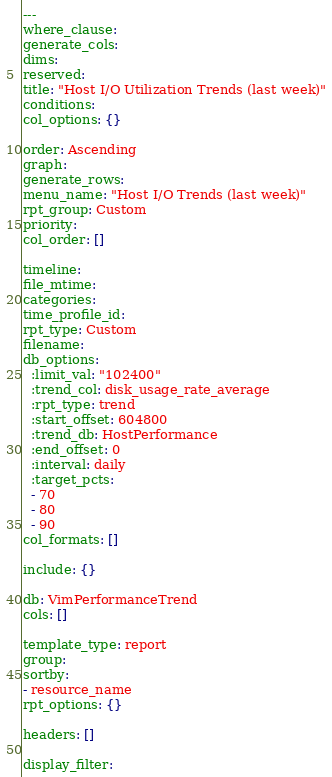Convert code to text. <code><loc_0><loc_0><loc_500><loc_500><_YAML_>---
where_clause:
generate_cols:
dims:
reserved:
title: "Host I/O Utilization Trends (last week)"
conditions:
col_options: {}

order: Ascending
graph:
generate_rows:
menu_name: "Host I/O Trends (last week)"
rpt_group: Custom
priority:
col_order: []

timeline:
file_mtime:
categories:
time_profile_id:
rpt_type: Custom
filename:
db_options:
  :limit_val: "102400"
  :trend_col: disk_usage_rate_average
  :rpt_type: trend
  :start_offset: 604800
  :trend_db: HostPerformance
  :end_offset: 0
  :interval: daily
  :target_pcts:
  - 70
  - 80
  - 90
col_formats: []

include: {}

db: VimPerformanceTrend
cols: []

template_type: report
group:
sortby:
- resource_name
rpt_options: {}

headers: []

display_filter:
</code> 